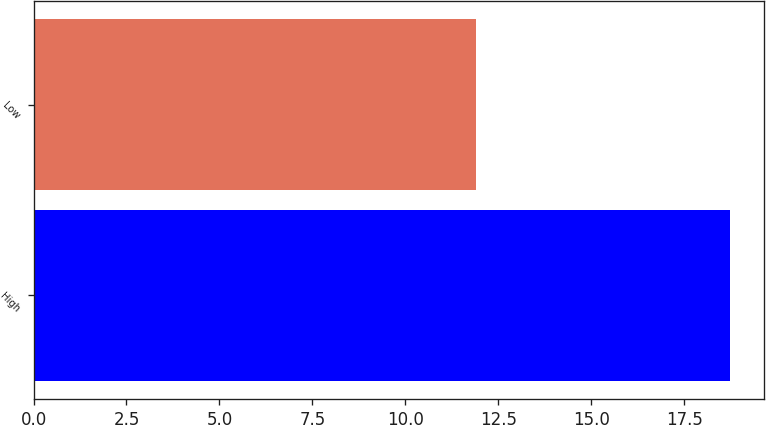Convert chart. <chart><loc_0><loc_0><loc_500><loc_500><bar_chart><fcel>High<fcel>Low<nl><fcel>18.72<fcel>11.9<nl></chart> 